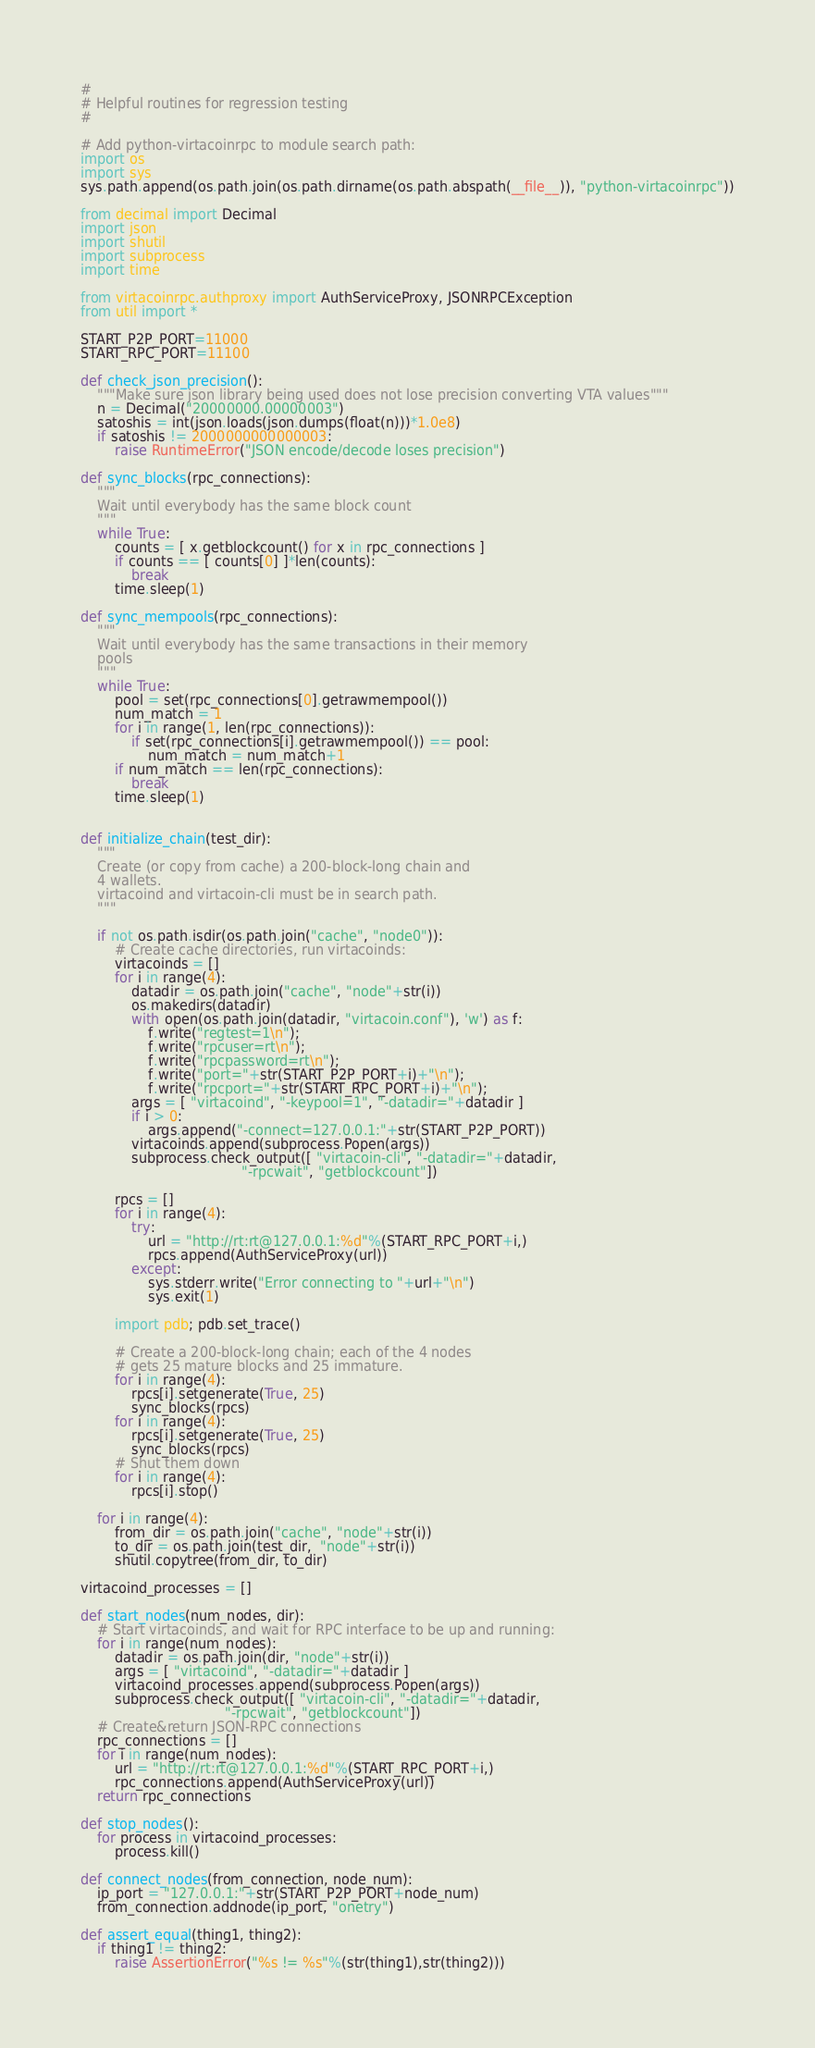Convert code to text. <code><loc_0><loc_0><loc_500><loc_500><_Python_>#
# Helpful routines for regression testing
#

# Add python-virtacoinrpc to module search path:
import os
import sys
sys.path.append(os.path.join(os.path.dirname(os.path.abspath(__file__)), "python-virtacoinrpc"))

from decimal import Decimal
import json
import shutil
import subprocess
import time

from virtacoinrpc.authproxy import AuthServiceProxy, JSONRPCException
from util import *

START_P2P_PORT=11000
START_RPC_PORT=11100

def check_json_precision():
    """Make sure json library being used does not lose precision converting VTA values"""
    n = Decimal("20000000.00000003")
    satoshis = int(json.loads(json.dumps(float(n)))*1.0e8)
    if satoshis != 2000000000000003:
        raise RuntimeError("JSON encode/decode loses precision")

def sync_blocks(rpc_connections):
    """
    Wait until everybody has the same block count
    """
    while True:
        counts = [ x.getblockcount() for x in rpc_connections ]
        if counts == [ counts[0] ]*len(counts):
            break
        time.sleep(1)

def sync_mempools(rpc_connections):
    """
    Wait until everybody has the same transactions in their memory
    pools
    """
    while True:
        pool = set(rpc_connections[0].getrawmempool())
        num_match = 1
        for i in range(1, len(rpc_connections)):
            if set(rpc_connections[i].getrawmempool()) == pool:
                num_match = num_match+1
        if num_match == len(rpc_connections):
            break
        time.sleep(1)
        

def initialize_chain(test_dir):
    """
    Create (or copy from cache) a 200-block-long chain and
    4 wallets.
    virtacoind and virtacoin-cli must be in search path.
    """

    if not os.path.isdir(os.path.join("cache", "node0")):
        # Create cache directories, run virtacoinds:
        virtacoinds = []
        for i in range(4):
            datadir = os.path.join("cache", "node"+str(i))
            os.makedirs(datadir)
            with open(os.path.join(datadir, "virtacoin.conf"), 'w') as f:
                f.write("regtest=1\n");
                f.write("rpcuser=rt\n");
                f.write("rpcpassword=rt\n");
                f.write("port="+str(START_P2P_PORT+i)+"\n");
                f.write("rpcport="+str(START_RPC_PORT+i)+"\n");
            args = [ "virtacoind", "-keypool=1", "-datadir="+datadir ]
            if i > 0:
                args.append("-connect=127.0.0.1:"+str(START_P2P_PORT))
            virtacoinds.append(subprocess.Popen(args))
            subprocess.check_output([ "virtacoin-cli", "-datadir="+datadir,
                                      "-rpcwait", "getblockcount"])

        rpcs = []
        for i in range(4):
            try:
                url = "http://rt:rt@127.0.0.1:%d"%(START_RPC_PORT+i,)
                rpcs.append(AuthServiceProxy(url))
            except:
                sys.stderr.write("Error connecting to "+url+"\n")
                sys.exit(1)

        import pdb; pdb.set_trace()

        # Create a 200-block-long chain; each of the 4 nodes
        # gets 25 mature blocks and 25 immature.
        for i in range(4):
            rpcs[i].setgenerate(True, 25)
            sync_blocks(rpcs)
        for i in range(4):
            rpcs[i].setgenerate(True, 25)
            sync_blocks(rpcs)
        # Shut them down
        for i in range(4):
            rpcs[i].stop()

    for i in range(4):
        from_dir = os.path.join("cache", "node"+str(i))
        to_dir = os.path.join(test_dir,  "node"+str(i))
        shutil.copytree(from_dir, to_dir)

virtacoind_processes = []

def start_nodes(num_nodes, dir):
    # Start virtacoinds, and wait for RPC interface to be up and running:
    for i in range(num_nodes):
        datadir = os.path.join(dir, "node"+str(i))
        args = [ "virtacoind", "-datadir="+datadir ]
        virtacoind_processes.append(subprocess.Popen(args))
        subprocess.check_output([ "virtacoin-cli", "-datadir="+datadir,
                                  "-rpcwait", "getblockcount"])
    # Create&return JSON-RPC connections
    rpc_connections = []
    for i in range(num_nodes):
        url = "http://rt:rt@127.0.0.1:%d"%(START_RPC_PORT+i,)
        rpc_connections.append(AuthServiceProxy(url))
    return rpc_connections

def stop_nodes():
    for process in virtacoind_processes:
        process.kill()

def connect_nodes(from_connection, node_num):
    ip_port = "127.0.0.1:"+str(START_P2P_PORT+node_num)
    from_connection.addnode(ip_port, "onetry")

def assert_equal(thing1, thing2):
    if thing1 != thing2:
        raise AssertionError("%s != %s"%(str(thing1),str(thing2)))
</code> 